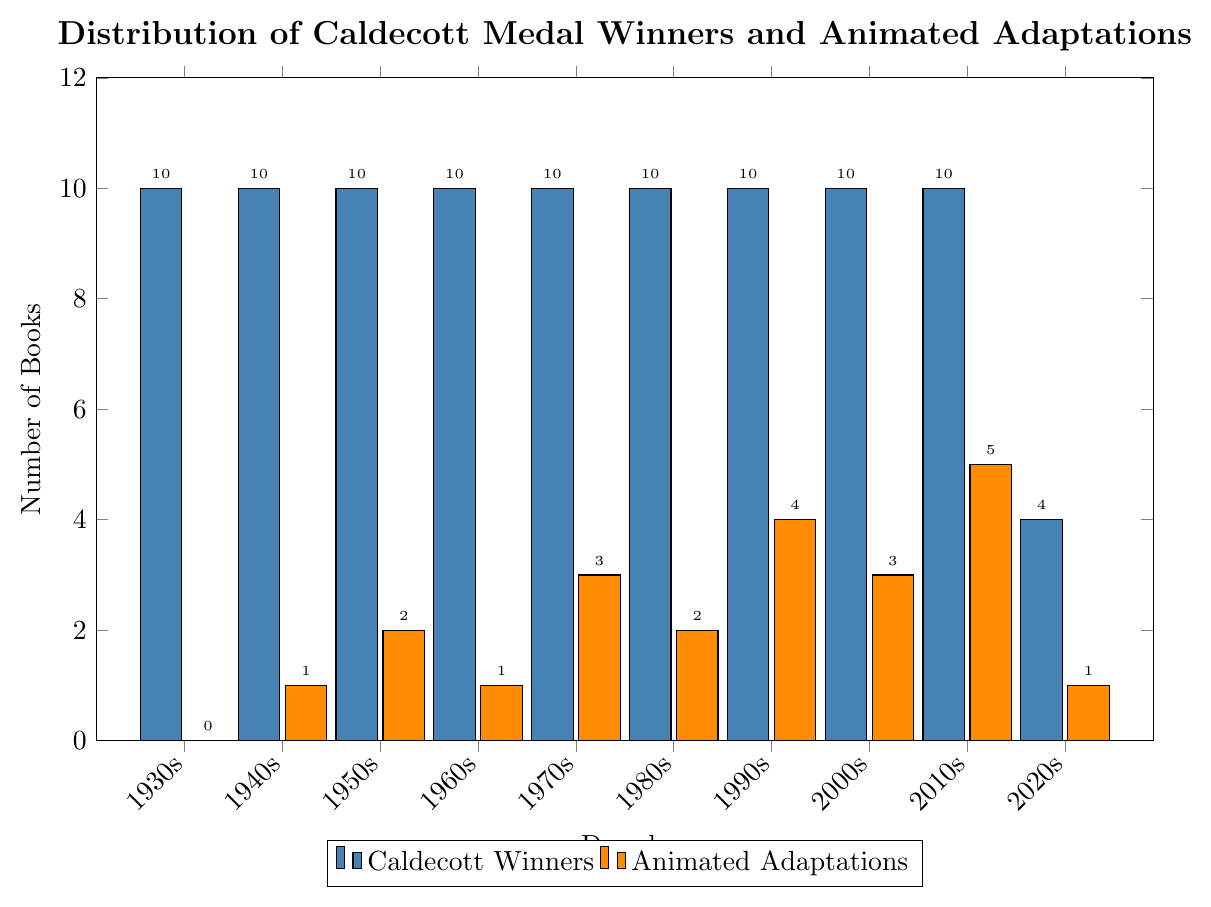How many total Caldecott Medal winners were there in the 1990s and 2000s combined? First, find the number of Caldecott Medal winners for the 1990s, which is 10, and for the 2000s, which is also 10. Then, add them together: 10 + 10 = 20.
Answer: 20 How many more animated adaptations were there in the 2010s compared to the 1940s? First, find the number of animated adaptations in the 2010s, which is 5, and in the 1940s, which is 1. Then, subtract the number for the 1940s from the number for the 2010s: 5 - 1 = 4.
Answer: 4 Which decade had the highest number of animated adaptations? Look at the figure to find the decade with the highest bar in the "Animated Adaptations" category. The 2010s had the highest number of animated adaptations with 5.
Answer: 2010s What is the average number of animated adaptations per decade from the 1930s to the 2020s? Add the number of animated adaptations for each decade from the 1930s to the 2020s (0 + 1 + 2 + 1 + 3 + 2 + 4 + 3 + 5 + 1 = 22). Then, divide by the number of decades (10): 22 / 10 = 2.2.
Answer: 2.2 How many more Caldecott Medal winners were there in the 1930s compared to the 2020s? Find the number of Caldecott Medal winners for the 1930s, which is 10, and for the 2020s, which is 4. Then, subtract the number for the 2020s from the number for the 1930s: 10 - 4 = 6.
Answer: 6 Which decade had the lowest number of animated adaptations? Look at the figure to find the decade with the lowest bar in the "Animated Adaptations" category. The 1930s had the lowest number of animated adaptations with 0.
Answer: 1930s How does the number of animated adaptations in the 1970s compare to the number in the 1950s? Find the number of animated adaptations for the 1970s, which is 3, and for the 1950s, which is 2. Since 3 is greater than 2, there were more adaptations in the 1970s than in the 1950s.
Answer: 3 is greater than 2 What is the total number of animated adaptations from the 1950s to the 1980s? Add the number of animated adaptations for the 1950s (2), 1960s (1), 1970s (3), and 1980s (2): 2 + 1 + 3 + 2 = 8.
Answer: 8 Compare the height of the bars for the Caldecott winners and animated adaptations in the 2010s. Which is taller? The bar for Caldecott winners in the 2010s is at 10, and the bar for animated adaptations is at 5. The bar for Caldecott winners is taller.
Answer: Caldecott winners If you sum the Caldecott winners and animated adaptations for the 1940s, what is the result? Add the number of Caldecott winners (10) and animated adaptations (1) for the 1940s: 10 + 1 = 11.
Answer: 11 